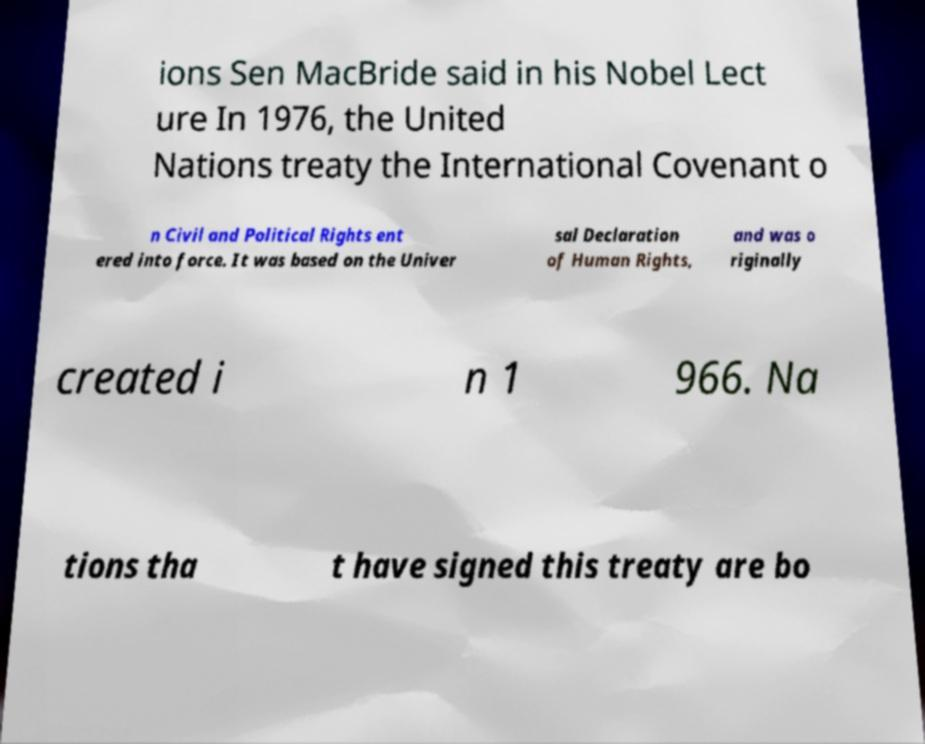Can you accurately transcribe the text from the provided image for me? ions Sen MacBride said in his Nobel Lect ure In 1976, the United Nations treaty the International Covenant o n Civil and Political Rights ent ered into force. It was based on the Univer sal Declaration of Human Rights, and was o riginally created i n 1 966. Na tions tha t have signed this treaty are bo 